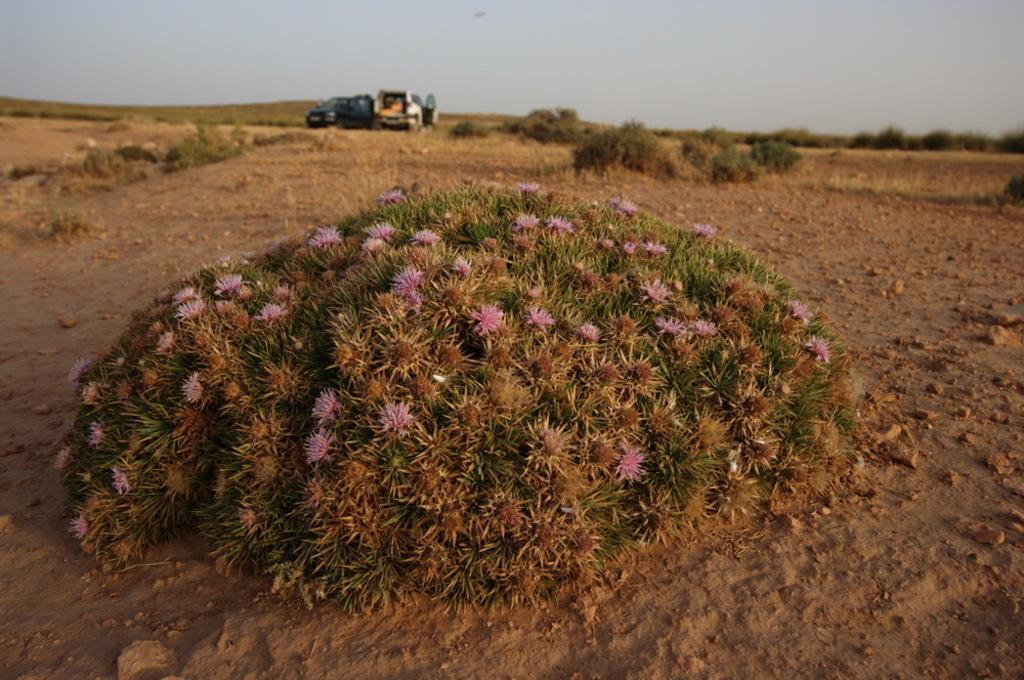Describe this image in one or two sentences. In this image in the center there is a plant and some flowers, at the bottom there is sand and in the background there is vehicle, people and some plants and sand. At the top there is sky. 